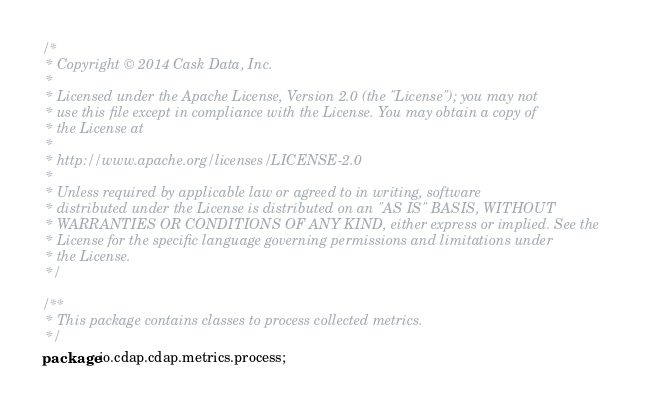Convert code to text. <code><loc_0><loc_0><loc_500><loc_500><_Java_>/*
 * Copyright © 2014 Cask Data, Inc.
 *
 * Licensed under the Apache License, Version 2.0 (the "License"); you may not
 * use this file except in compliance with the License. You may obtain a copy of
 * the License at
 *
 * http://www.apache.org/licenses/LICENSE-2.0
 *
 * Unless required by applicable law or agreed to in writing, software
 * distributed under the License is distributed on an "AS IS" BASIS, WITHOUT
 * WARRANTIES OR CONDITIONS OF ANY KIND, either express or implied. See the
 * License for the specific language governing permissions and limitations under
 * the License.
 */

/**
 * This package contains classes to process collected metrics.
 */
package io.cdap.cdap.metrics.process;
</code> 